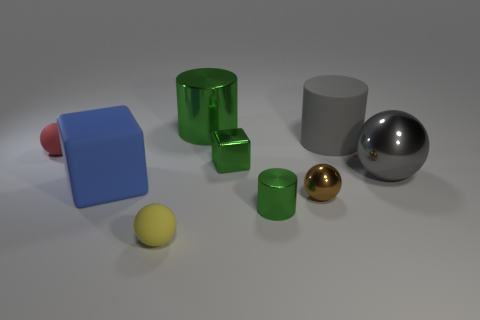Subtract all green cylinders. How many cylinders are left? 1 Subtract all red blocks. How many green cylinders are left? 2 Add 1 small red matte cylinders. How many objects exist? 10 Subtract all yellow balls. How many balls are left? 3 Subtract all yellow balls. Subtract all yellow cylinders. How many balls are left? 3 Add 6 red matte balls. How many red matte balls exist? 7 Subtract 0 yellow cubes. How many objects are left? 9 Subtract all cylinders. How many objects are left? 6 Subtract all tiny objects. Subtract all green balls. How many objects are left? 4 Add 9 red objects. How many red objects are left? 10 